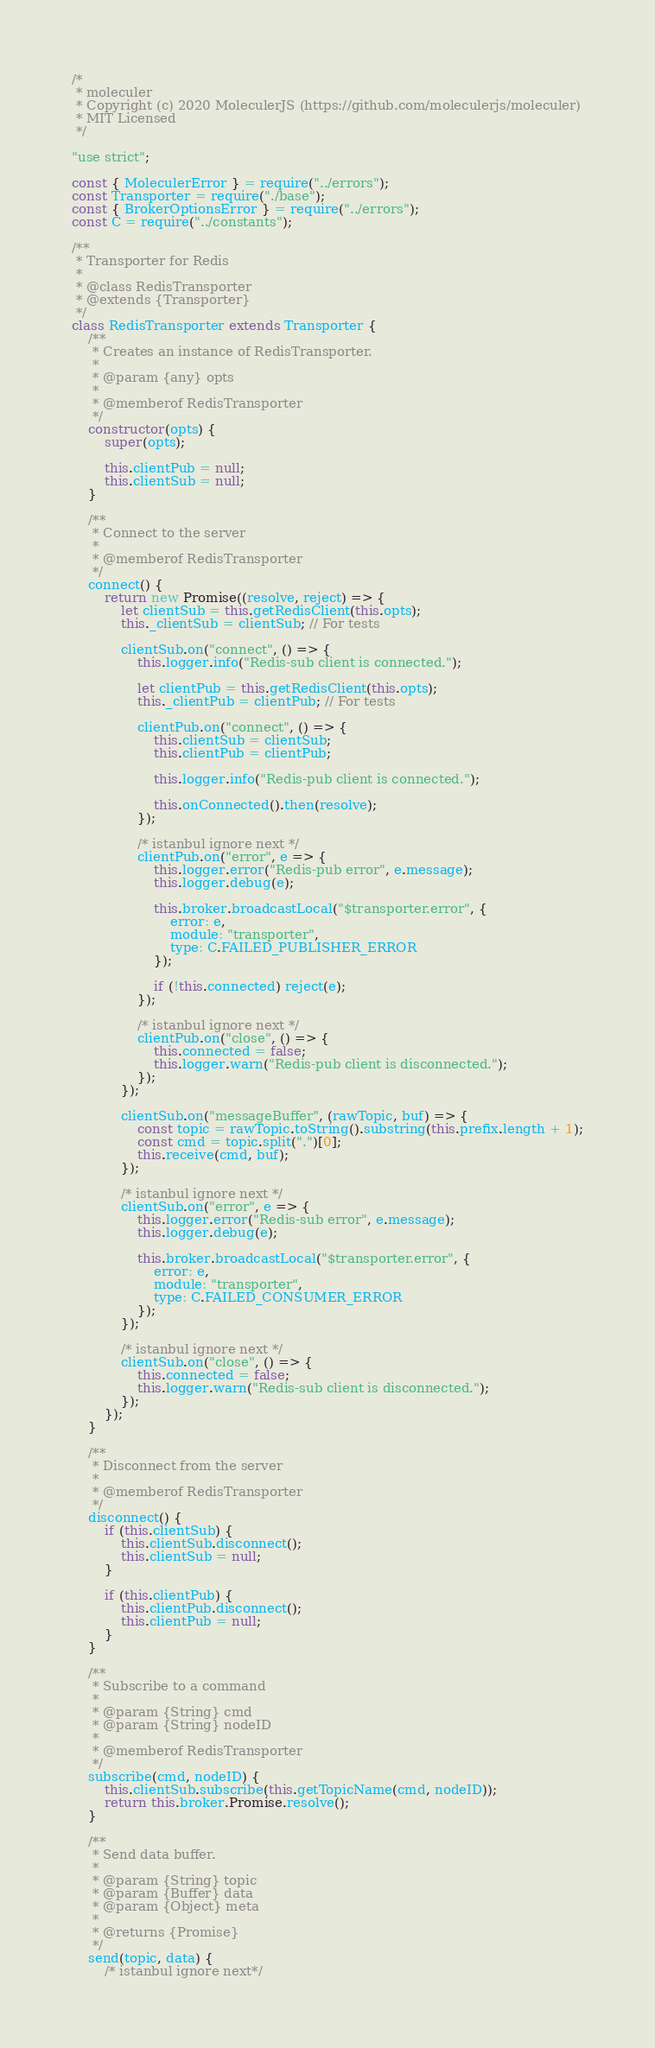<code> <loc_0><loc_0><loc_500><loc_500><_JavaScript_>/*
 * moleculer
 * Copyright (c) 2020 MoleculerJS (https://github.com/moleculerjs/moleculer)
 * MIT Licensed
 */

"use strict";

const { MoleculerError } = require("../errors");
const Transporter = require("./base");
const { BrokerOptionsError } = require("../errors");
const C = require("../constants");

/**
 * Transporter for Redis
 *
 * @class RedisTransporter
 * @extends {Transporter}
 */
class RedisTransporter extends Transporter {
	/**
	 * Creates an instance of RedisTransporter.
	 *
	 * @param {any} opts
	 *
	 * @memberof RedisTransporter
	 */
	constructor(opts) {
		super(opts);

		this.clientPub = null;
		this.clientSub = null;
	}

	/**
	 * Connect to the server
	 *
	 * @memberof RedisTransporter
	 */
	connect() {
		return new Promise((resolve, reject) => {
			let clientSub = this.getRedisClient(this.opts);
			this._clientSub = clientSub; // For tests

			clientSub.on("connect", () => {
				this.logger.info("Redis-sub client is connected.");

				let clientPub = this.getRedisClient(this.opts);
				this._clientPub = clientPub; // For tests

				clientPub.on("connect", () => {
					this.clientSub = clientSub;
					this.clientPub = clientPub;

					this.logger.info("Redis-pub client is connected.");

					this.onConnected().then(resolve);
				});

				/* istanbul ignore next */
				clientPub.on("error", e => {
					this.logger.error("Redis-pub error", e.message);
					this.logger.debug(e);

					this.broker.broadcastLocal("$transporter.error", {
						error: e,
						module: "transporter",
						type: C.FAILED_PUBLISHER_ERROR
					});

					if (!this.connected) reject(e);
				});

				/* istanbul ignore next */
				clientPub.on("close", () => {
					this.connected = false;
					this.logger.warn("Redis-pub client is disconnected.");
				});
			});

			clientSub.on("messageBuffer", (rawTopic, buf) => {
				const topic = rawTopic.toString().substring(this.prefix.length + 1);
				const cmd = topic.split(".")[0];
				this.receive(cmd, buf);
			});

			/* istanbul ignore next */
			clientSub.on("error", e => {
				this.logger.error("Redis-sub error", e.message);
				this.logger.debug(e);

				this.broker.broadcastLocal("$transporter.error", {
					error: e,
					module: "transporter",
					type: C.FAILED_CONSUMER_ERROR
				});
			});

			/* istanbul ignore next */
			clientSub.on("close", () => {
				this.connected = false;
				this.logger.warn("Redis-sub client is disconnected.");
			});
		});
	}

	/**
	 * Disconnect from the server
	 *
	 * @memberof RedisTransporter
	 */
	disconnect() {
		if (this.clientSub) {
			this.clientSub.disconnect();
			this.clientSub = null;
		}

		if (this.clientPub) {
			this.clientPub.disconnect();
			this.clientPub = null;
		}
	}

	/**
	 * Subscribe to a command
	 *
	 * @param {String} cmd
	 * @param {String} nodeID
	 *
	 * @memberof RedisTransporter
	 */
	subscribe(cmd, nodeID) {
		this.clientSub.subscribe(this.getTopicName(cmd, nodeID));
		return this.broker.Promise.resolve();
	}

	/**
	 * Send data buffer.
	 *
	 * @param {String} topic
	 * @param {Buffer} data
	 * @param {Object} meta
	 *
	 * @returns {Promise}
	 */
	send(topic, data) {
		/* istanbul ignore next*/</code> 